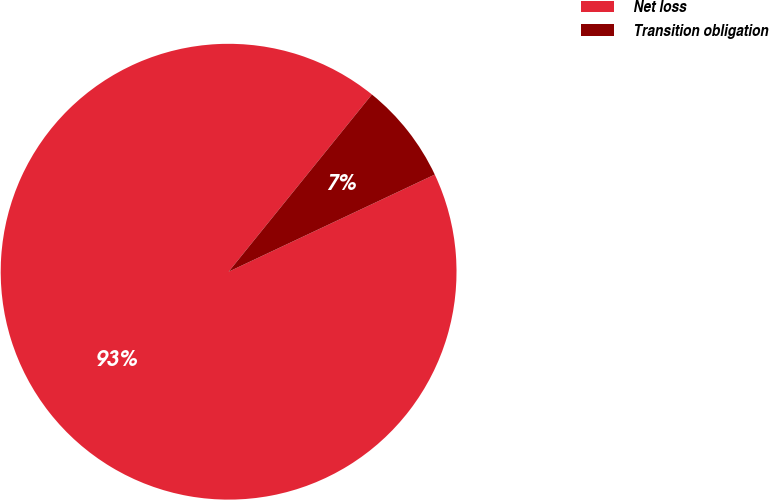Convert chart to OTSL. <chart><loc_0><loc_0><loc_500><loc_500><pie_chart><fcel>Net loss<fcel>Transition obligation<nl><fcel>92.83%<fcel>7.17%<nl></chart> 